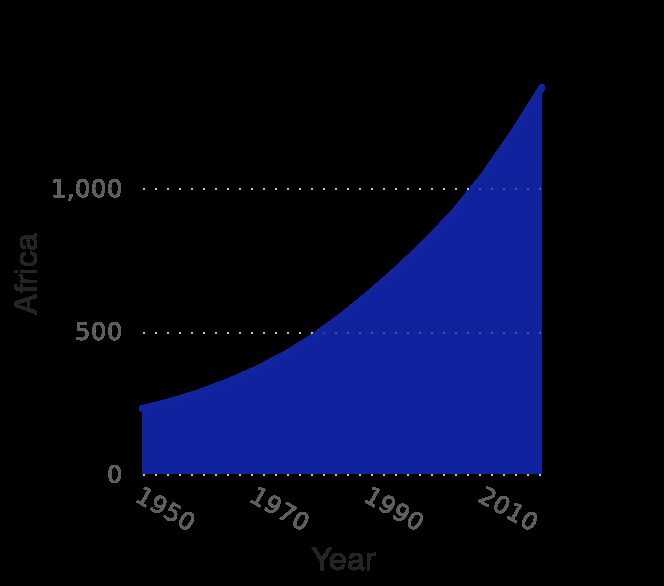<image>
What is the scale used for plotting the population of Africa on the y-axis?  The scale used for plotting the population of Africa on the y-axis is a linear scale ranging from 0 to 1,000 (in millions). What time period does the area diagram cover? The area diagram covers the time period from 1950 to 2020. please summary the statistics and relations of the chart In 1980 the population of Africa was 500 million. In 2006 the population of Africa was a billion. 